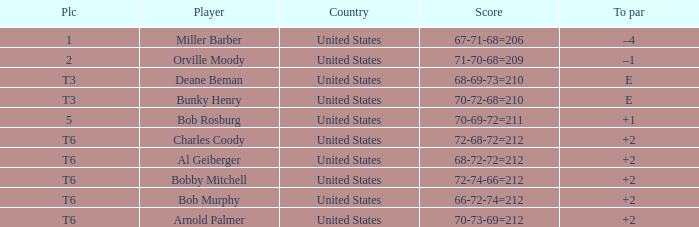What is the score of player bob rosburg? 70-69-72=211. 